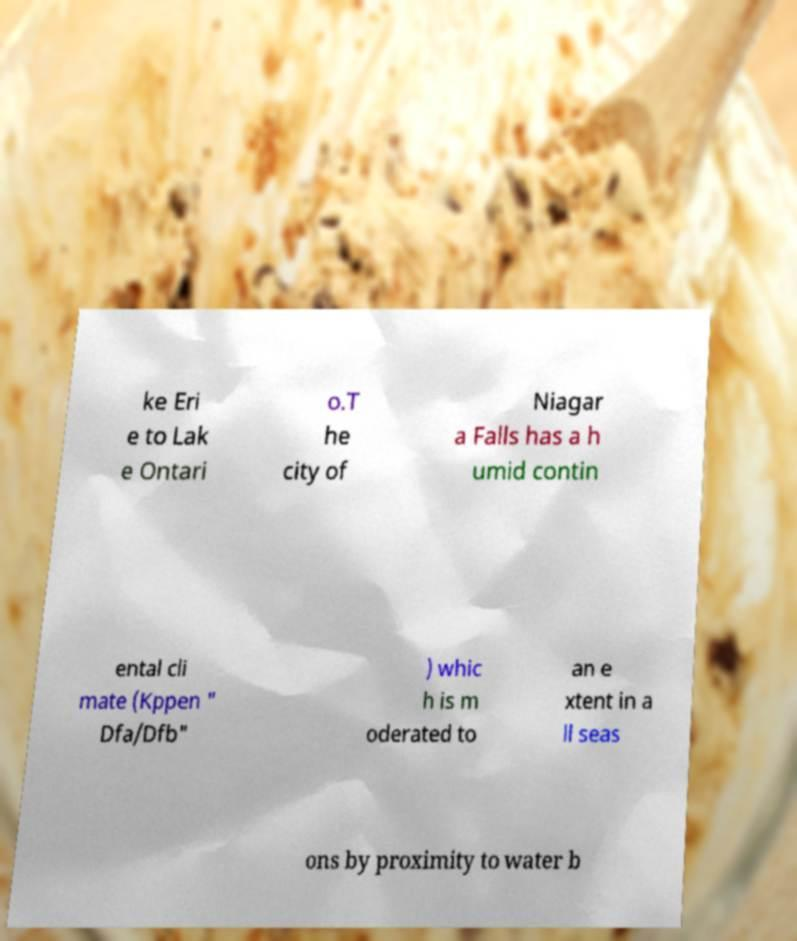I need the written content from this picture converted into text. Can you do that? ke Eri e to Lak e Ontari o.T he city of Niagar a Falls has a h umid contin ental cli mate (Kppen " Dfa/Dfb" ) whic h is m oderated to an e xtent in a ll seas ons by proximity to water b 